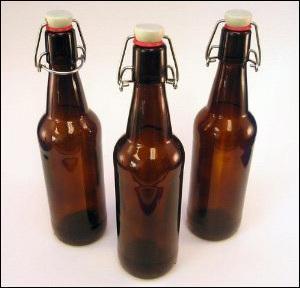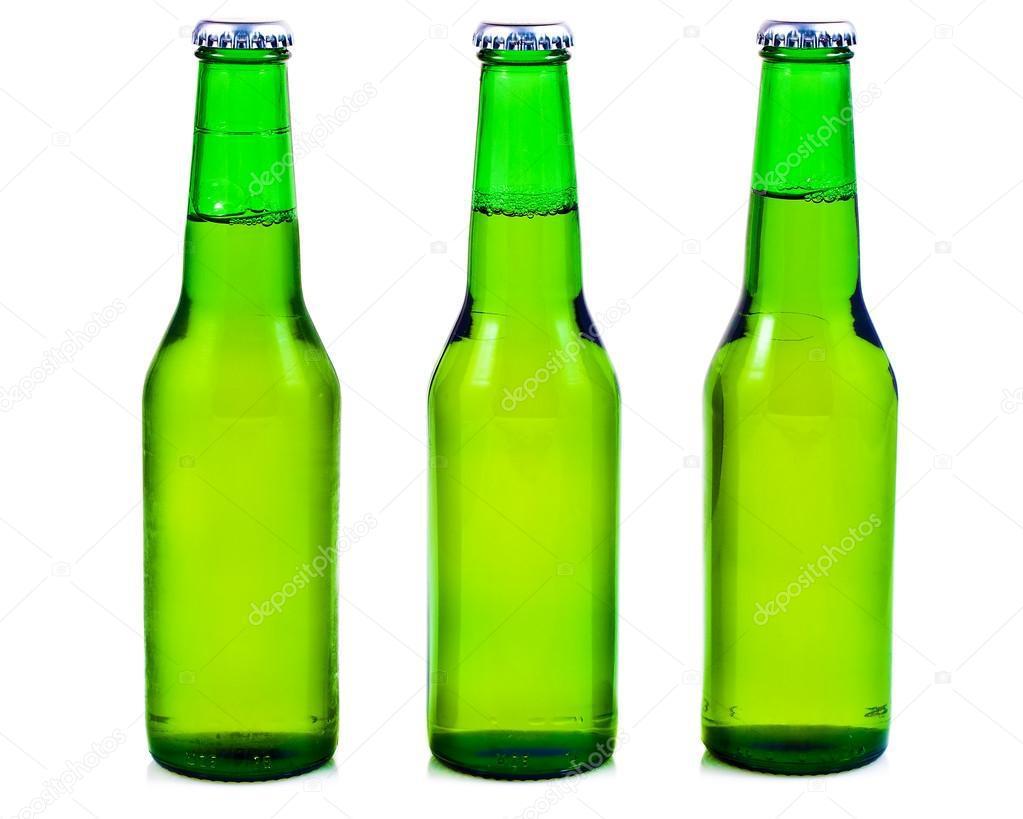The first image is the image on the left, the second image is the image on the right. Evaluate the accuracy of this statement regarding the images: "there are six bottles". Is it true? Answer yes or no. Yes. The first image is the image on the left, the second image is the image on the right. Given the left and right images, does the statement "Three identical green bottles are standing in a row." hold true? Answer yes or no. Yes. 